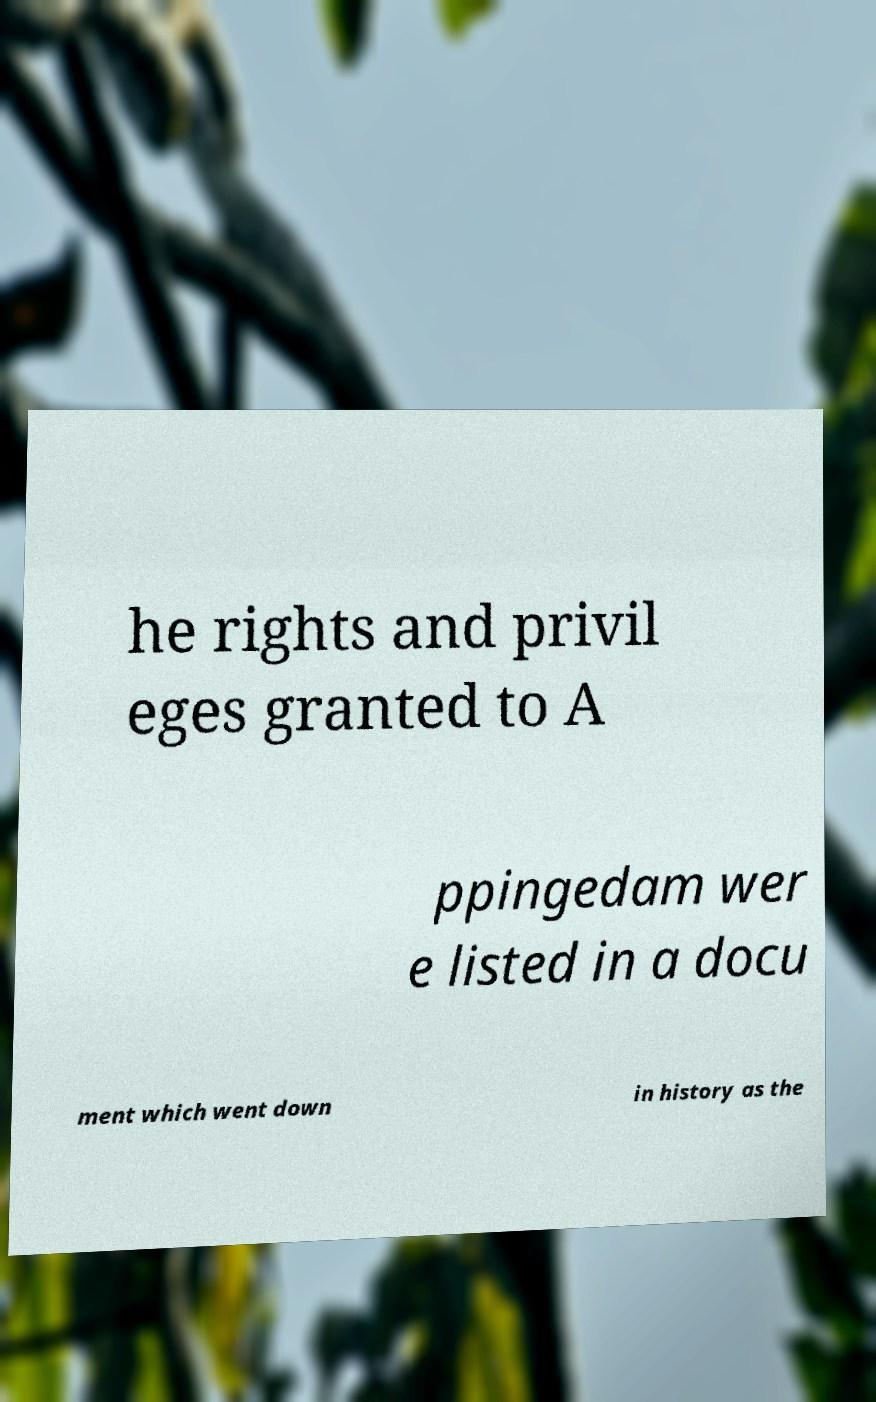Please identify and transcribe the text found in this image. he rights and privil eges granted to A ppingedam wer e listed in a docu ment which went down in history as the 